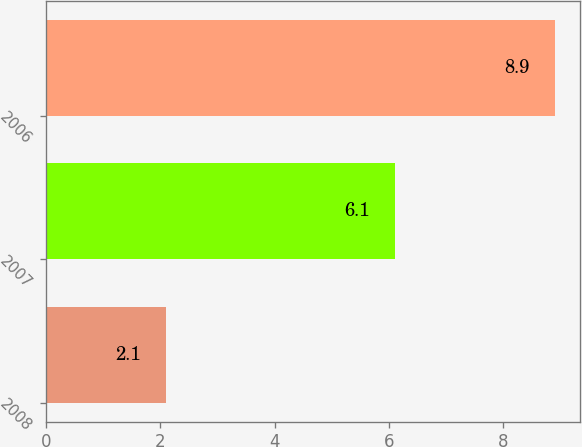Convert chart to OTSL. <chart><loc_0><loc_0><loc_500><loc_500><bar_chart><fcel>2008<fcel>2007<fcel>2006<nl><fcel>2.1<fcel>6.1<fcel>8.9<nl></chart> 